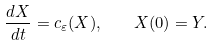<formula> <loc_0><loc_0><loc_500><loc_500>\frac { d X } { d t } = c _ { \varepsilon } ( X ) , \quad X ( 0 ) = Y .</formula> 